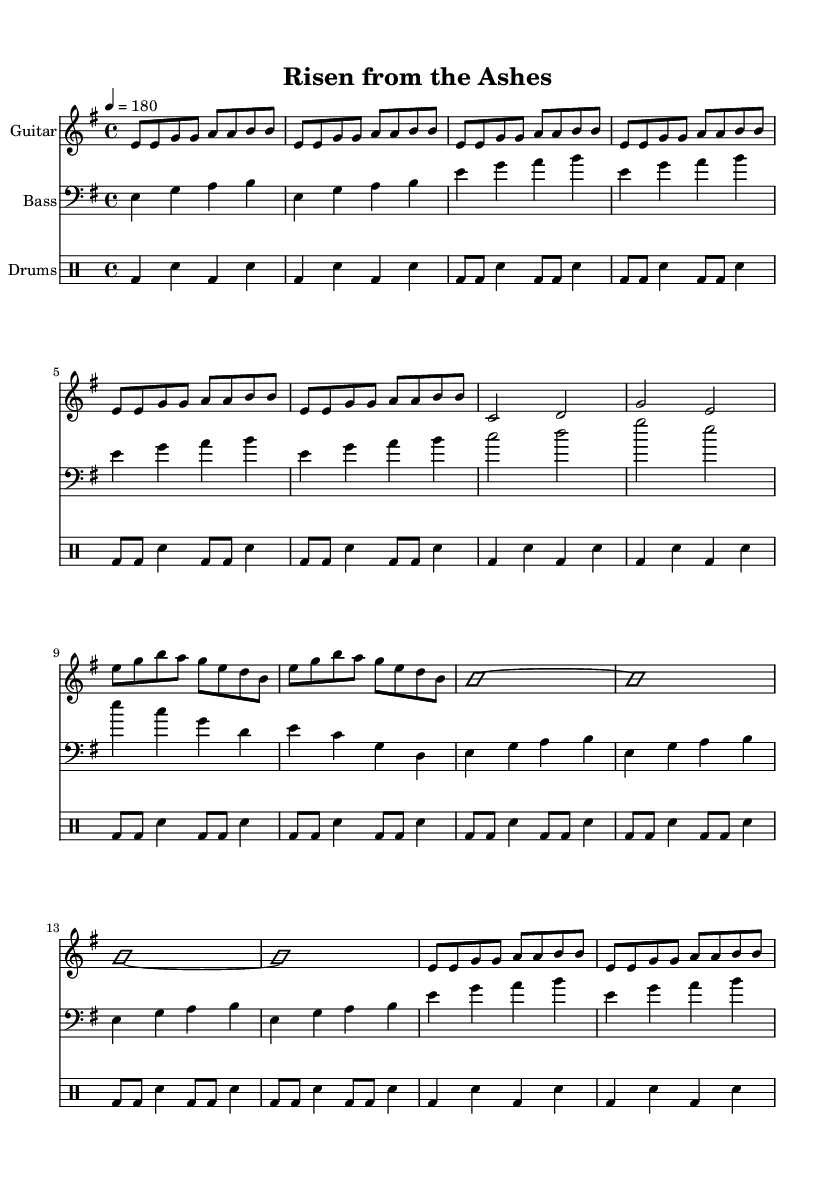What is the key signature of this music? The key signature is indicated at the beginning of the staff. Here, it shows one sharp, which indicates it's in E minor.
Answer: E minor What is the time signature of this piece? The time signature is located at the beginning of the music, represented as a fraction. In this case, it shows 4 over 4, which means there are four beats in each measure.
Answer: 4/4 What is the tempo of the piece? The tempo marking is specified at the beginning, showing a quarter note equals 180, which provides the speed of the music.
Answer: 180 How many times is the intro riff repeated? Looking at the sheet, the intro riff shows a repeat indication followed by the measure length. It is written to repeat twice before moving to the verse.
Answer: 2 What instrument is primarily featured in this piece? The instrument is named in the staff titles, where it specifies "Guitar." It's also indicated as the primary leading instrument throughout the piece.
Answer: Guitar What types of sections are present in the music? By analyzing the structure indicated in the sheet music, we can see sections like "Intro," "Verse," "Pre-chorus," "Chorus," "Solo," and "Outro," which are common in power metal music.
Answer: Intro, Verse, Pre-chorus, Chorus, Solo, Outro What is the rhythmic pattern used for the drums in the verse? The rhythmic pattern can be discerned from the drum section in the sheet music. It indicates alternate bass and snare hits in a consistent eighth-note rhythm with accented beats.
Answer: Bass and snare alternation 